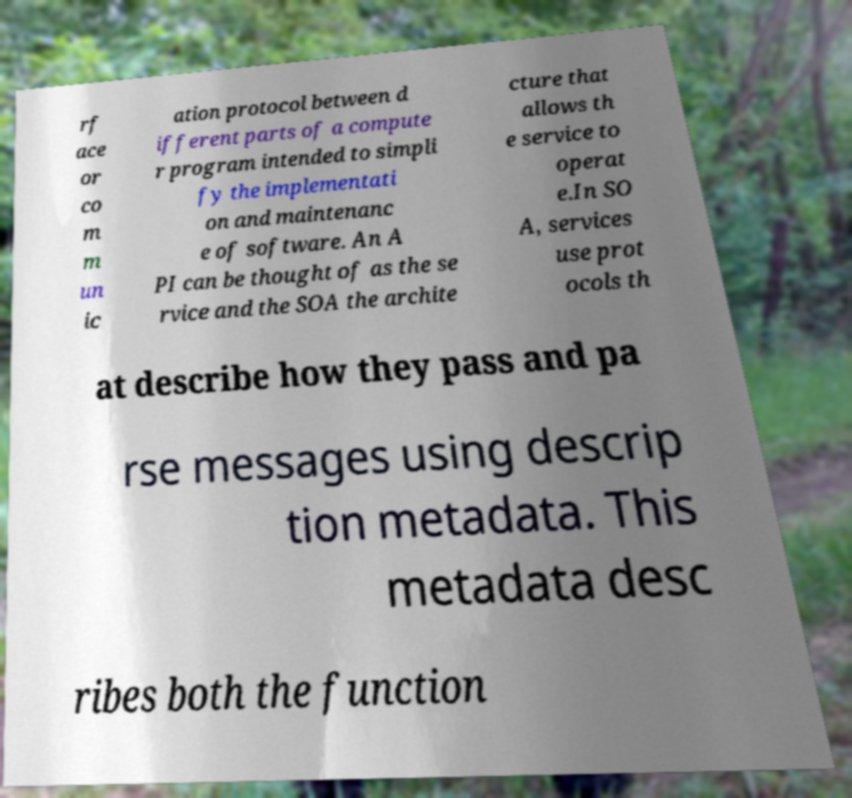Can you accurately transcribe the text from the provided image for me? rf ace or co m m un ic ation protocol between d ifferent parts of a compute r program intended to simpli fy the implementati on and maintenanc e of software. An A PI can be thought of as the se rvice and the SOA the archite cture that allows th e service to operat e.In SO A, services use prot ocols th at describe how they pass and pa rse messages using descrip tion metadata. This metadata desc ribes both the function 